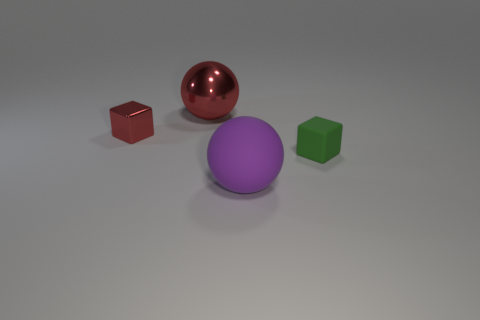Add 1 large brown metal cylinders. How many objects exist? 5 Add 1 big yellow matte spheres. How many big yellow matte spheres exist? 1 Subtract 0 purple cylinders. How many objects are left? 4 Subtract all large purple balls. Subtract all metal objects. How many objects are left? 1 Add 4 big red things. How many big red things are left? 5 